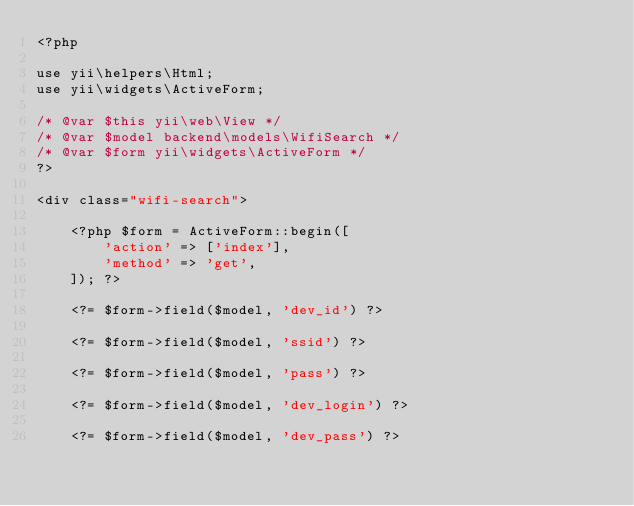<code> <loc_0><loc_0><loc_500><loc_500><_PHP_><?php

use yii\helpers\Html;
use yii\widgets\ActiveForm;

/* @var $this yii\web\View */
/* @var $model backend\models\WifiSearch */
/* @var $form yii\widgets\ActiveForm */
?>

<div class="wifi-search">

    <?php $form = ActiveForm::begin([
        'action' => ['index'],
        'method' => 'get',
    ]); ?>

    <?= $form->field($model, 'dev_id') ?>

    <?= $form->field($model, 'ssid') ?>

    <?= $form->field($model, 'pass') ?>

    <?= $form->field($model, 'dev_login') ?>

    <?= $form->field($model, 'dev_pass') ?>
</code> 